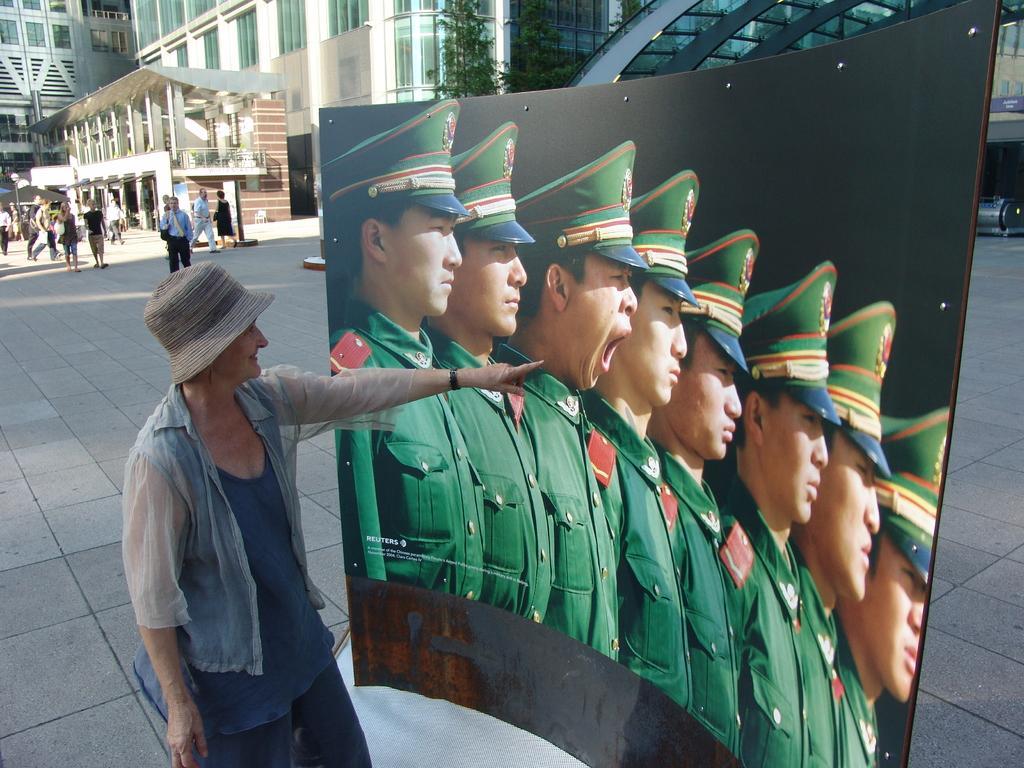Can you describe this image briefly? In this image we can see a woman standing on the ground. We can also see a board in front of her in which we can see the picture of a group of people standing. On the backside we can see a some people, buildings with windows, a pole and some trees. 